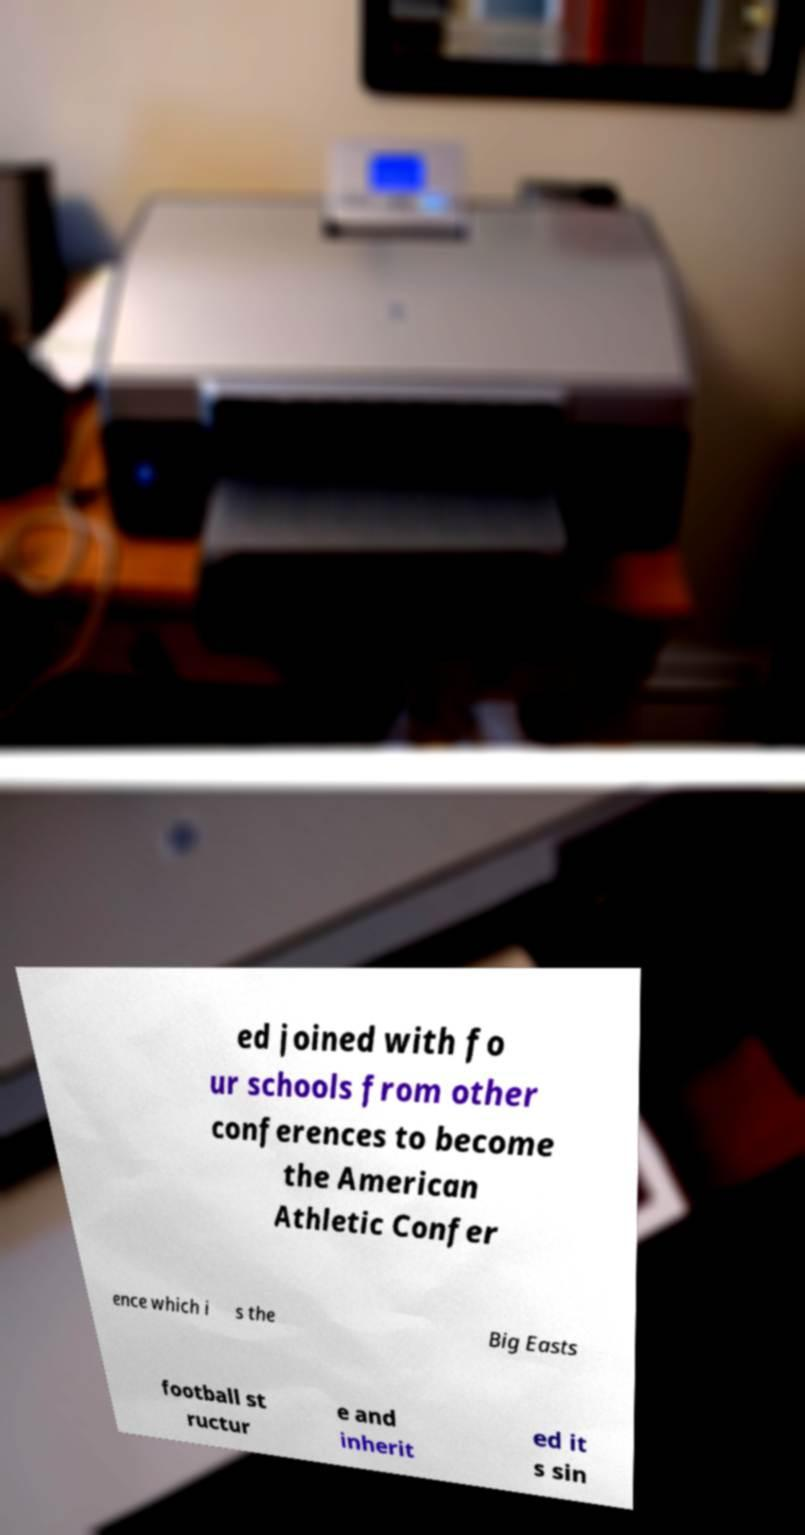There's text embedded in this image that I need extracted. Can you transcribe it verbatim? ed joined with fo ur schools from other conferences to become the American Athletic Confer ence which i s the Big Easts football st ructur e and inherit ed it s sin 